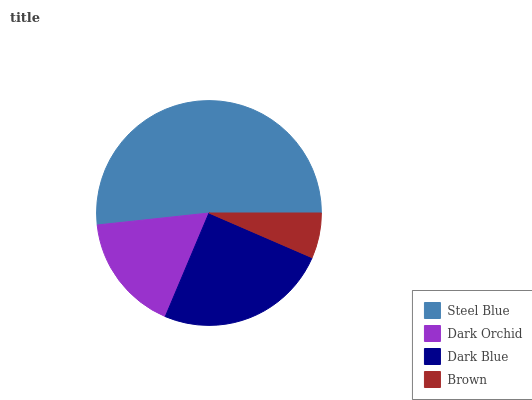Is Brown the minimum?
Answer yes or no. Yes. Is Steel Blue the maximum?
Answer yes or no. Yes. Is Dark Orchid the minimum?
Answer yes or no. No. Is Dark Orchid the maximum?
Answer yes or no. No. Is Steel Blue greater than Dark Orchid?
Answer yes or no. Yes. Is Dark Orchid less than Steel Blue?
Answer yes or no. Yes. Is Dark Orchid greater than Steel Blue?
Answer yes or no. No. Is Steel Blue less than Dark Orchid?
Answer yes or no. No. Is Dark Blue the high median?
Answer yes or no. Yes. Is Dark Orchid the low median?
Answer yes or no. Yes. Is Dark Orchid the high median?
Answer yes or no. No. Is Brown the low median?
Answer yes or no. No. 